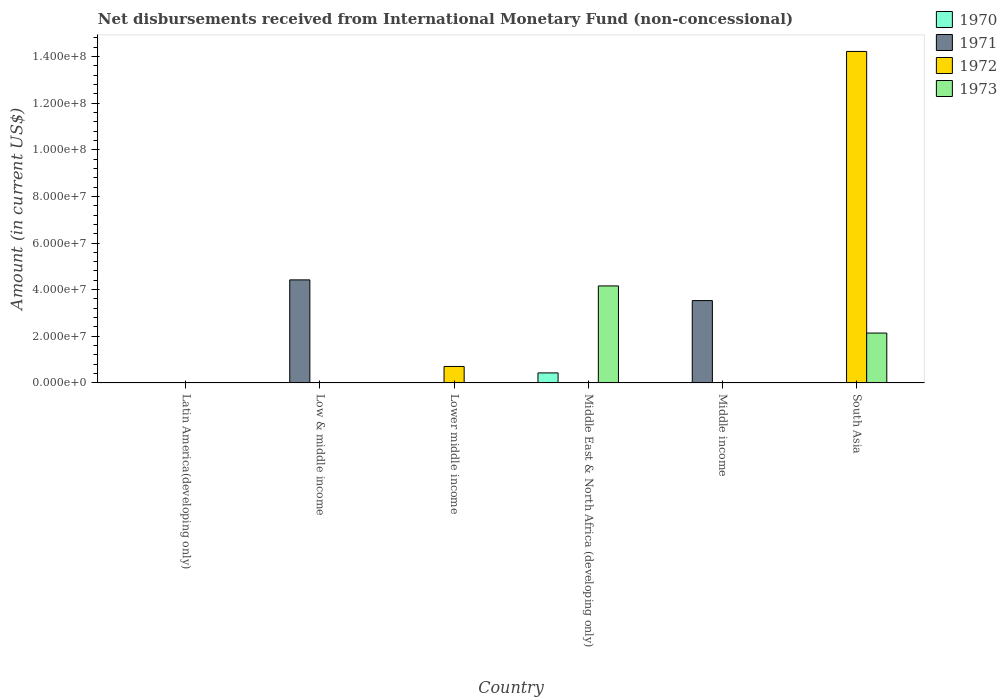Are the number of bars per tick equal to the number of legend labels?
Your answer should be very brief. No. How many bars are there on the 1st tick from the left?
Give a very brief answer. 0. How many bars are there on the 4th tick from the right?
Offer a very short reply. 1. What is the label of the 1st group of bars from the left?
Your answer should be very brief. Latin America(developing only). In how many cases, is the number of bars for a given country not equal to the number of legend labels?
Your response must be concise. 6. What is the amount of disbursements received from International Monetary Fund in 1973 in Lower middle income?
Offer a very short reply. 0. Across all countries, what is the maximum amount of disbursements received from International Monetary Fund in 1973?
Provide a succinct answer. 4.16e+07. In which country was the amount of disbursements received from International Monetary Fund in 1970 maximum?
Offer a terse response. Middle East & North Africa (developing only). What is the total amount of disbursements received from International Monetary Fund in 1971 in the graph?
Make the answer very short. 7.95e+07. What is the difference between the amount of disbursements received from International Monetary Fund in 1970 in Middle income and the amount of disbursements received from International Monetary Fund in 1972 in South Asia?
Offer a very short reply. -1.42e+08. What is the average amount of disbursements received from International Monetary Fund in 1970 per country?
Ensure brevity in your answer.  7.17e+05. What is the difference between the amount of disbursements received from International Monetary Fund of/in 1973 and amount of disbursements received from International Monetary Fund of/in 1972 in South Asia?
Your answer should be compact. -1.21e+08. What is the ratio of the amount of disbursements received from International Monetary Fund in 1973 in Middle East & North Africa (developing only) to that in South Asia?
Your response must be concise. 1.94. What is the difference between the highest and the lowest amount of disbursements received from International Monetary Fund in 1970?
Keep it short and to the point. 4.30e+06. In how many countries, is the amount of disbursements received from International Monetary Fund in 1971 greater than the average amount of disbursements received from International Monetary Fund in 1971 taken over all countries?
Keep it short and to the point. 2. Is it the case that in every country, the sum of the amount of disbursements received from International Monetary Fund in 1973 and amount of disbursements received from International Monetary Fund in 1970 is greater than the sum of amount of disbursements received from International Monetary Fund in 1972 and amount of disbursements received from International Monetary Fund in 1971?
Your answer should be very brief. No. How many countries are there in the graph?
Offer a terse response. 6. Are the values on the major ticks of Y-axis written in scientific E-notation?
Your response must be concise. Yes. Does the graph contain any zero values?
Your answer should be compact. Yes. Does the graph contain grids?
Provide a short and direct response. No. How are the legend labels stacked?
Provide a succinct answer. Vertical. What is the title of the graph?
Ensure brevity in your answer.  Net disbursements received from International Monetary Fund (non-concessional). What is the label or title of the X-axis?
Offer a terse response. Country. What is the Amount (in current US$) of 1970 in Low & middle income?
Your answer should be compact. 0. What is the Amount (in current US$) in 1971 in Low & middle income?
Make the answer very short. 4.42e+07. What is the Amount (in current US$) of 1972 in Low & middle income?
Offer a very short reply. 0. What is the Amount (in current US$) of 1970 in Lower middle income?
Provide a succinct answer. 0. What is the Amount (in current US$) of 1971 in Lower middle income?
Provide a succinct answer. 0. What is the Amount (in current US$) in 1972 in Lower middle income?
Provide a short and direct response. 7.06e+06. What is the Amount (in current US$) of 1973 in Lower middle income?
Offer a very short reply. 0. What is the Amount (in current US$) of 1970 in Middle East & North Africa (developing only)?
Give a very brief answer. 4.30e+06. What is the Amount (in current US$) of 1971 in Middle East & North Africa (developing only)?
Offer a very short reply. 0. What is the Amount (in current US$) of 1973 in Middle East & North Africa (developing only)?
Offer a very short reply. 4.16e+07. What is the Amount (in current US$) in 1970 in Middle income?
Make the answer very short. 0. What is the Amount (in current US$) of 1971 in Middle income?
Keep it short and to the point. 3.53e+07. What is the Amount (in current US$) of 1970 in South Asia?
Provide a short and direct response. 0. What is the Amount (in current US$) of 1972 in South Asia?
Make the answer very short. 1.42e+08. What is the Amount (in current US$) of 1973 in South Asia?
Ensure brevity in your answer.  2.14e+07. Across all countries, what is the maximum Amount (in current US$) of 1970?
Give a very brief answer. 4.30e+06. Across all countries, what is the maximum Amount (in current US$) of 1971?
Make the answer very short. 4.42e+07. Across all countries, what is the maximum Amount (in current US$) of 1972?
Offer a very short reply. 1.42e+08. Across all countries, what is the maximum Amount (in current US$) in 1973?
Offer a terse response. 4.16e+07. Across all countries, what is the minimum Amount (in current US$) of 1970?
Ensure brevity in your answer.  0. Across all countries, what is the minimum Amount (in current US$) of 1971?
Offer a very short reply. 0. Across all countries, what is the minimum Amount (in current US$) of 1972?
Offer a terse response. 0. Across all countries, what is the minimum Amount (in current US$) in 1973?
Offer a terse response. 0. What is the total Amount (in current US$) of 1970 in the graph?
Your answer should be very brief. 4.30e+06. What is the total Amount (in current US$) of 1971 in the graph?
Your response must be concise. 7.95e+07. What is the total Amount (in current US$) of 1972 in the graph?
Give a very brief answer. 1.49e+08. What is the total Amount (in current US$) of 1973 in the graph?
Keep it short and to the point. 6.30e+07. What is the difference between the Amount (in current US$) of 1971 in Low & middle income and that in Middle income?
Ensure brevity in your answer.  8.88e+06. What is the difference between the Amount (in current US$) in 1972 in Lower middle income and that in South Asia?
Give a very brief answer. -1.35e+08. What is the difference between the Amount (in current US$) of 1973 in Middle East & North Africa (developing only) and that in South Asia?
Keep it short and to the point. 2.02e+07. What is the difference between the Amount (in current US$) of 1971 in Low & middle income and the Amount (in current US$) of 1972 in Lower middle income?
Ensure brevity in your answer.  3.71e+07. What is the difference between the Amount (in current US$) in 1971 in Low & middle income and the Amount (in current US$) in 1973 in Middle East & North Africa (developing only)?
Give a very brief answer. 2.60e+06. What is the difference between the Amount (in current US$) of 1971 in Low & middle income and the Amount (in current US$) of 1972 in South Asia?
Give a very brief answer. -9.79e+07. What is the difference between the Amount (in current US$) of 1971 in Low & middle income and the Amount (in current US$) of 1973 in South Asia?
Your answer should be compact. 2.28e+07. What is the difference between the Amount (in current US$) in 1972 in Lower middle income and the Amount (in current US$) in 1973 in Middle East & North Africa (developing only)?
Provide a short and direct response. -3.45e+07. What is the difference between the Amount (in current US$) in 1972 in Lower middle income and the Amount (in current US$) in 1973 in South Asia?
Offer a terse response. -1.43e+07. What is the difference between the Amount (in current US$) of 1970 in Middle East & North Africa (developing only) and the Amount (in current US$) of 1971 in Middle income?
Your answer should be compact. -3.10e+07. What is the difference between the Amount (in current US$) of 1970 in Middle East & North Africa (developing only) and the Amount (in current US$) of 1972 in South Asia?
Make the answer very short. -1.38e+08. What is the difference between the Amount (in current US$) in 1970 in Middle East & North Africa (developing only) and the Amount (in current US$) in 1973 in South Asia?
Offer a very short reply. -1.71e+07. What is the difference between the Amount (in current US$) of 1971 in Middle income and the Amount (in current US$) of 1972 in South Asia?
Your answer should be very brief. -1.07e+08. What is the difference between the Amount (in current US$) in 1971 in Middle income and the Amount (in current US$) in 1973 in South Asia?
Keep it short and to the point. 1.39e+07. What is the average Amount (in current US$) in 1970 per country?
Offer a very short reply. 7.17e+05. What is the average Amount (in current US$) of 1971 per country?
Offer a terse response. 1.32e+07. What is the average Amount (in current US$) in 1972 per country?
Provide a succinct answer. 2.49e+07. What is the average Amount (in current US$) in 1973 per country?
Ensure brevity in your answer.  1.05e+07. What is the difference between the Amount (in current US$) in 1970 and Amount (in current US$) in 1973 in Middle East & North Africa (developing only)?
Keep it short and to the point. -3.73e+07. What is the difference between the Amount (in current US$) in 1972 and Amount (in current US$) in 1973 in South Asia?
Offer a very short reply. 1.21e+08. What is the ratio of the Amount (in current US$) of 1971 in Low & middle income to that in Middle income?
Keep it short and to the point. 1.25. What is the ratio of the Amount (in current US$) of 1972 in Lower middle income to that in South Asia?
Your answer should be very brief. 0.05. What is the ratio of the Amount (in current US$) of 1973 in Middle East & North Africa (developing only) to that in South Asia?
Your answer should be compact. 1.94. What is the difference between the highest and the lowest Amount (in current US$) of 1970?
Make the answer very short. 4.30e+06. What is the difference between the highest and the lowest Amount (in current US$) of 1971?
Your response must be concise. 4.42e+07. What is the difference between the highest and the lowest Amount (in current US$) of 1972?
Offer a terse response. 1.42e+08. What is the difference between the highest and the lowest Amount (in current US$) of 1973?
Your answer should be compact. 4.16e+07. 